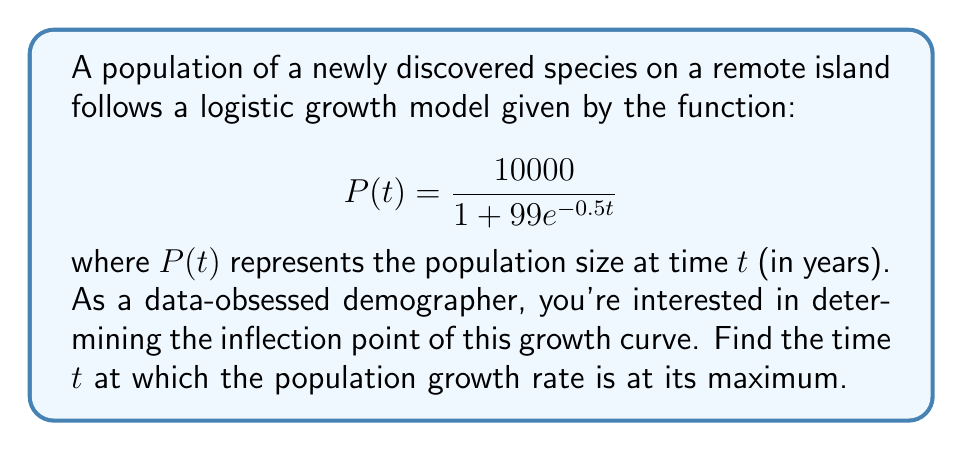Teach me how to tackle this problem. To find the inflection point of a logistic growth curve, we need to follow these steps:

1) The inflection point occurs when the second derivative of $P(t)$ equals zero. Let's start by finding the first and second derivatives.

2) First derivative:
   $$P'(t) = \frac{10000 \cdot 99 \cdot 0.5e^{-0.5t}}{(1 + 99e^{-0.5t})^2}$$

3) Second derivative:
   $$P''(t) = \frac{10000 \cdot 99 \cdot 0.5^2e^{-0.5t}(99e^{-0.5t} - 1)}{(1 + 99e^{-0.5t})^3}$$

4) Set $P''(t) = 0$ and solve for $t$:
   $$\frac{10000 \cdot 99 \cdot 0.5^2e^{-0.5t}(99e^{-0.5t} - 1)}{(1 + 99e^{-0.5t})^3} = 0$$

5) The numerator will be zero when:
   $$99e^{-0.5t} - 1 = 0$$

6) Solve this equation:
   $$99e^{-0.5t} = 1$$
   $$e^{-0.5t} = \frac{1}{99}$$
   $$-0.5t = \ln(\frac{1}{99})$$
   $$t = -2\ln(\frac{1}{99}) = 2\ln(99)$$

7) Therefore, the inflection point occurs at $t = 2\ln(99)$ years.

This is the point where the population growth rate is at its maximum, after which it will start to slow down as the population approaches its carrying capacity.
Answer: $2\ln(99)$ years 